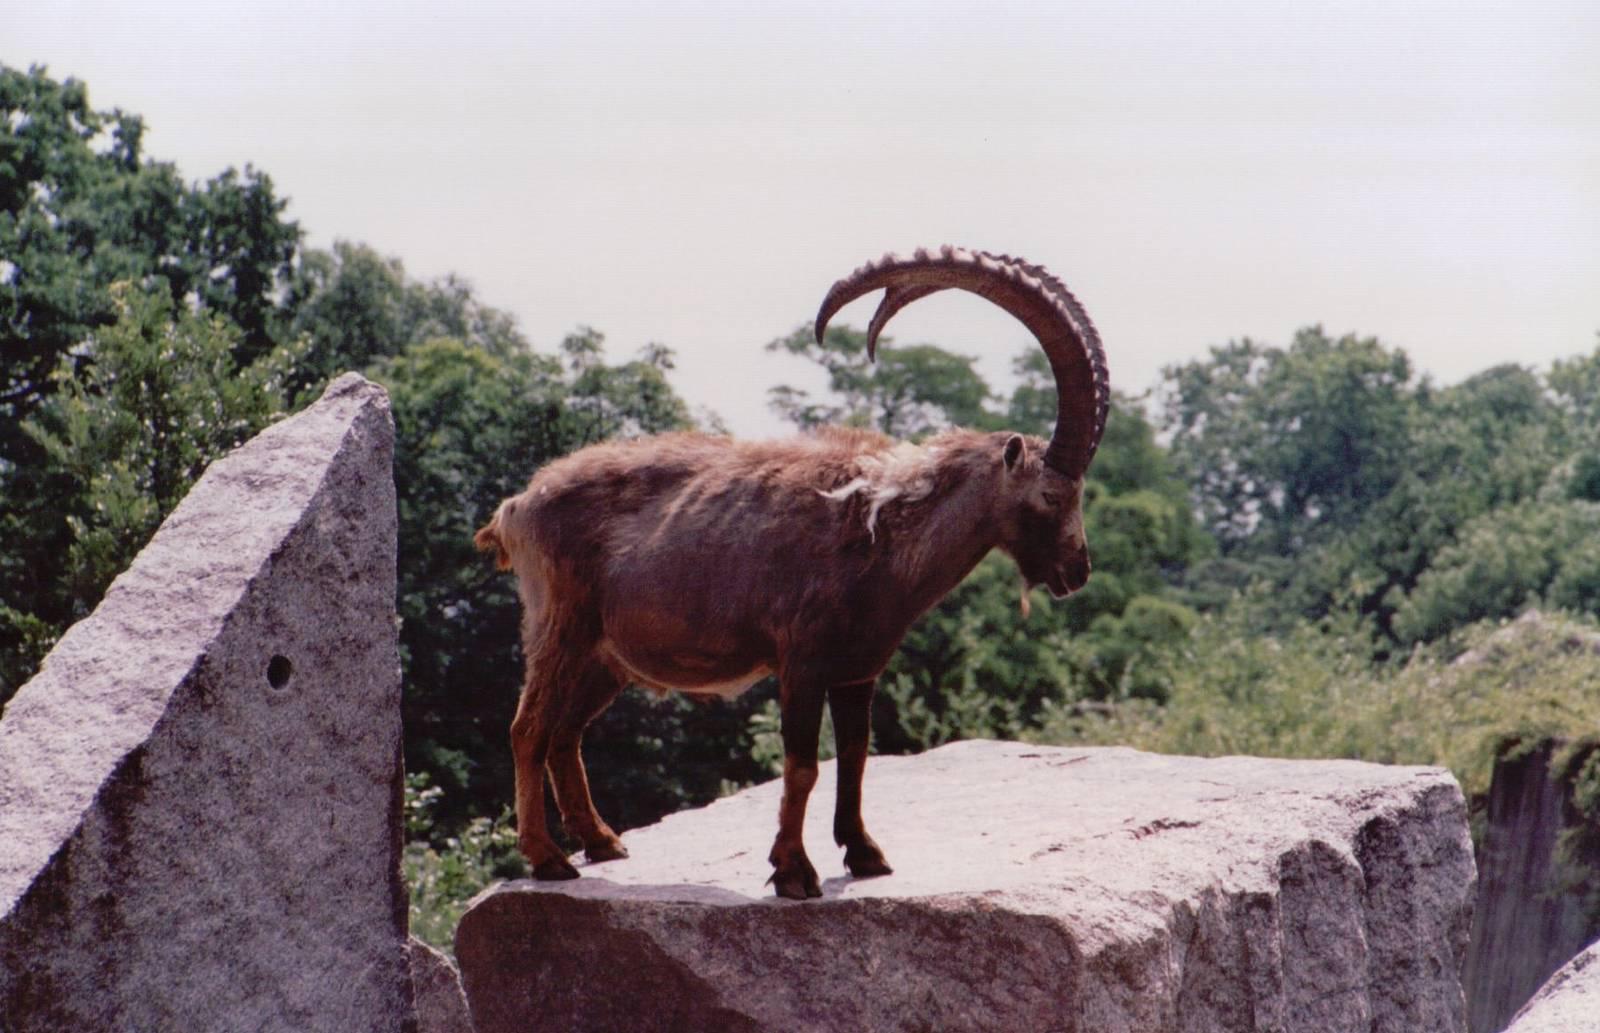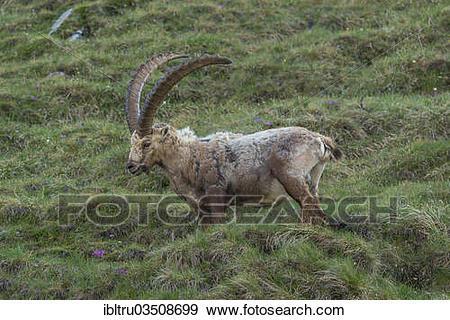The first image is the image on the left, the second image is the image on the right. Examine the images to the left and right. Is the description "A different kind of animal is behind a sheep with a large set of horns in one image." accurate? Answer yes or no. No. The first image is the image on the left, the second image is the image on the right. Given the left and right images, does the statement "The sky can be seen in the image on the right." hold true? Answer yes or no. No. 